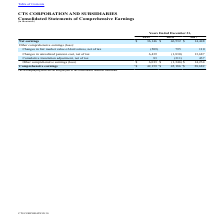From Cts Corporation's financial document, Which years does the table provide information for the company's Consolidated Statements of Comprehensive Earnings? The document contains multiple relevant values: 2019, 2018, 2017. From the document: "2019 2018 2017 2019 2018 2017 2019 2018 2017..." Also, What were the net earnings in 2019? According to the financial document, 36,146 (in thousands). The relevant text states: "Net earnings $ 36,146 $ 46,532 $ 14,448..." Also, What was the Changes in fair market value of derivatives, net of tax in 2018? According to the financial document, 795 (in thousands). The relevant text states: "air market value of derivatives, net of tax (509) 795 110..." Also, How many years did net earnings exceed $30,000 thousand? Counting the relevant items in the document: 2019, 2018, I find 2 instances. The key data points involved are: 2018, 2019. Also, can you calculate: What was the change in the Other comprehensive earnings  between 2017 and 2019? Based on the calculation: 6,013-14,234, the result is -8221 (in thousands). This is based on the information: "Other comprehensive earnings (loss) $ 6,013 $ (1,346) $ 14,234 comprehensive earnings (loss) $ 6,013 $ (1,346) $ 14,234..." The key data points involved are: 14,234, 6,013. Also, can you calculate: What was the percentage change in Comprehensive earnings between 2017 and 2018? To answer this question, I need to perform calculations using the financial data. The calculation is: (45,186-28,682)/28,682, which equals 57.54 (percentage). This is based on the information: "Comprehensive earnings $ 42,159 $ 45,186 $ 28,682 Comprehensive earnings $ 42,159 $ 45,186 $ 28,682..." The key data points involved are: 28,682, 45,186. 